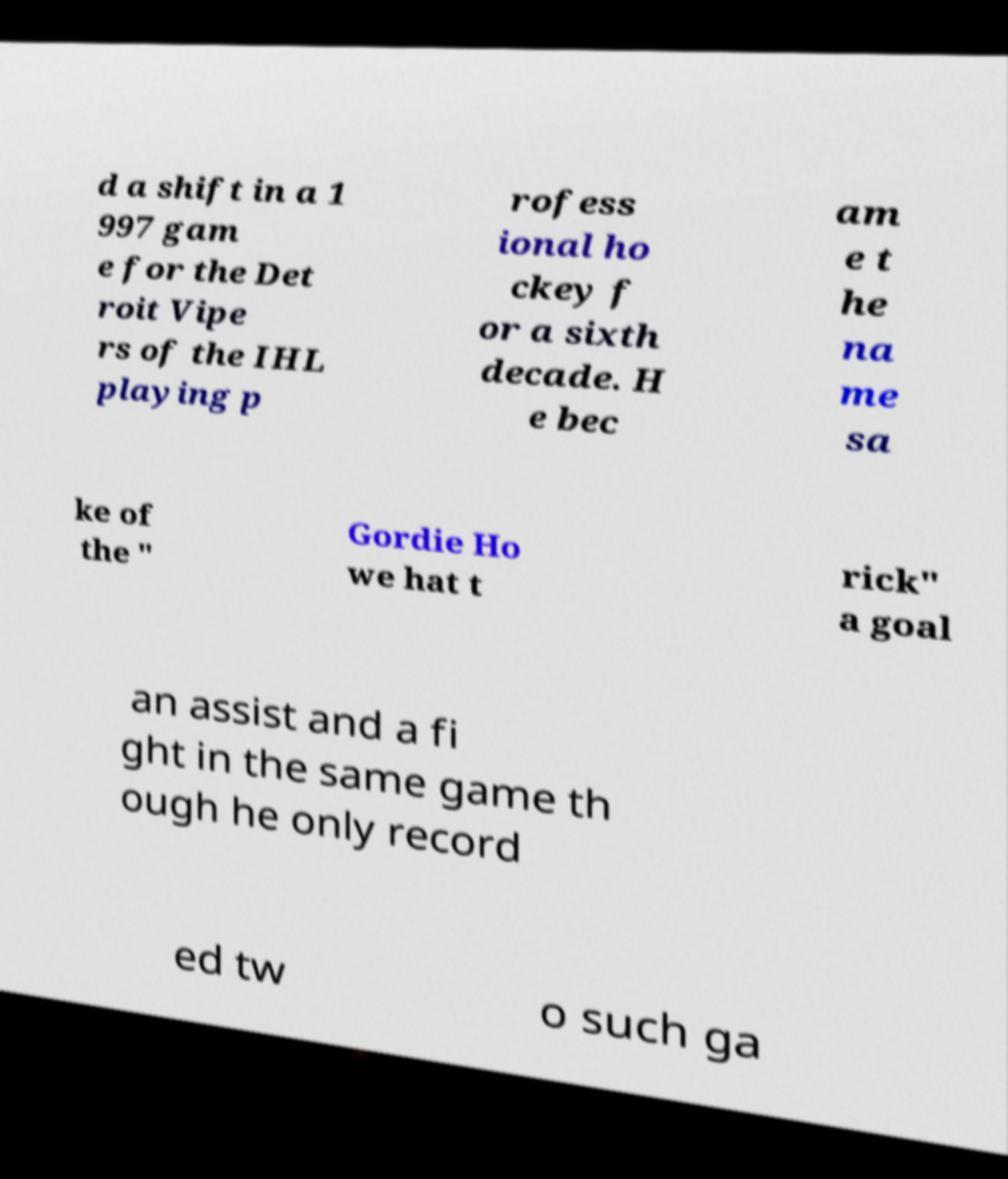Can you read and provide the text displayed in the image?This photo seems to have some interesting text. Can you extract and type it out for me? d a shift in a 1 997 gam e for the Det roit Vipe rs of the IHL playing p rofess ional ho ckey f or a sixth decade. H e bec am e t he na me sa ke of the " Gordie Ho we hat t rick" a goal an assist and a fi ght in the same game th ough he only record ed tw o such ga 